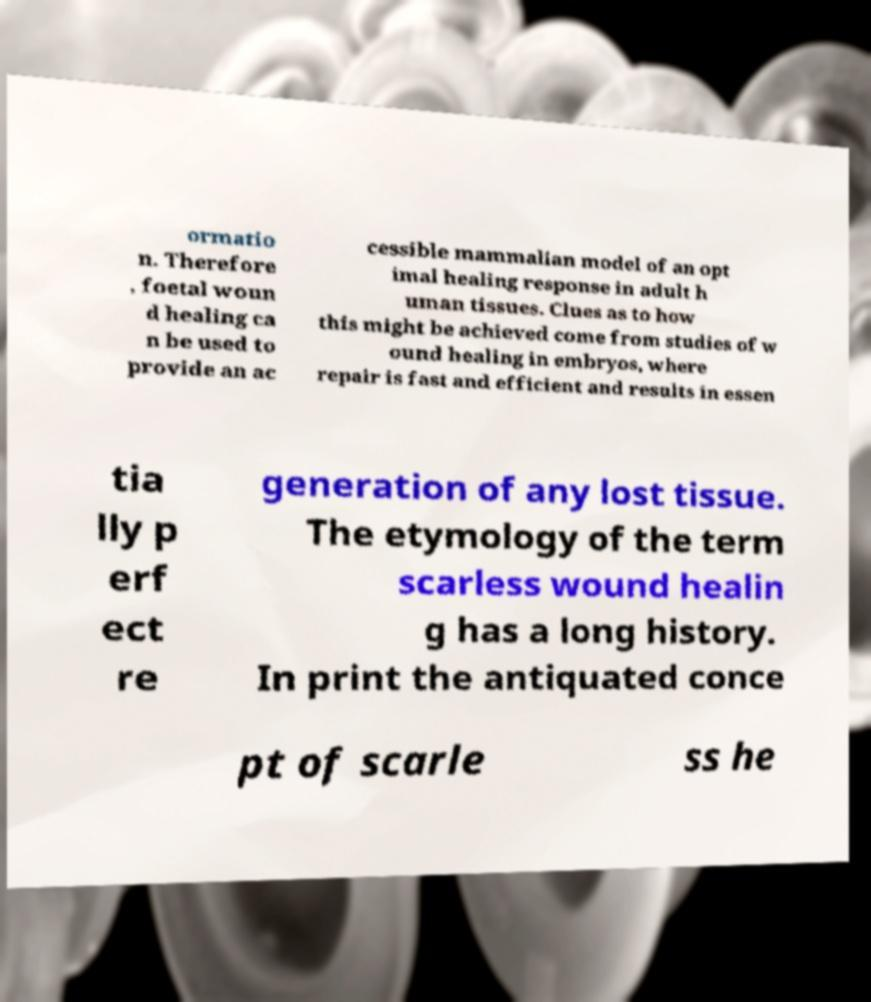Could you assist in decoding the text presented in this image and type it out clearly? ormatio n. Therefore , foetal woun d healing ca n be used to provide an ac cessible mammalian model of an opt imal healing response in adult h uman tissues. Clues as to how this might be achieved come from studies of w ound healing in embryos, where repair is fast and efficient and results in essen tia lly p erf ect re generation of any lost tissue. The etymology of the term scarless wound healin g has a long history. In print the antiquated conce pt of scarle ss he 